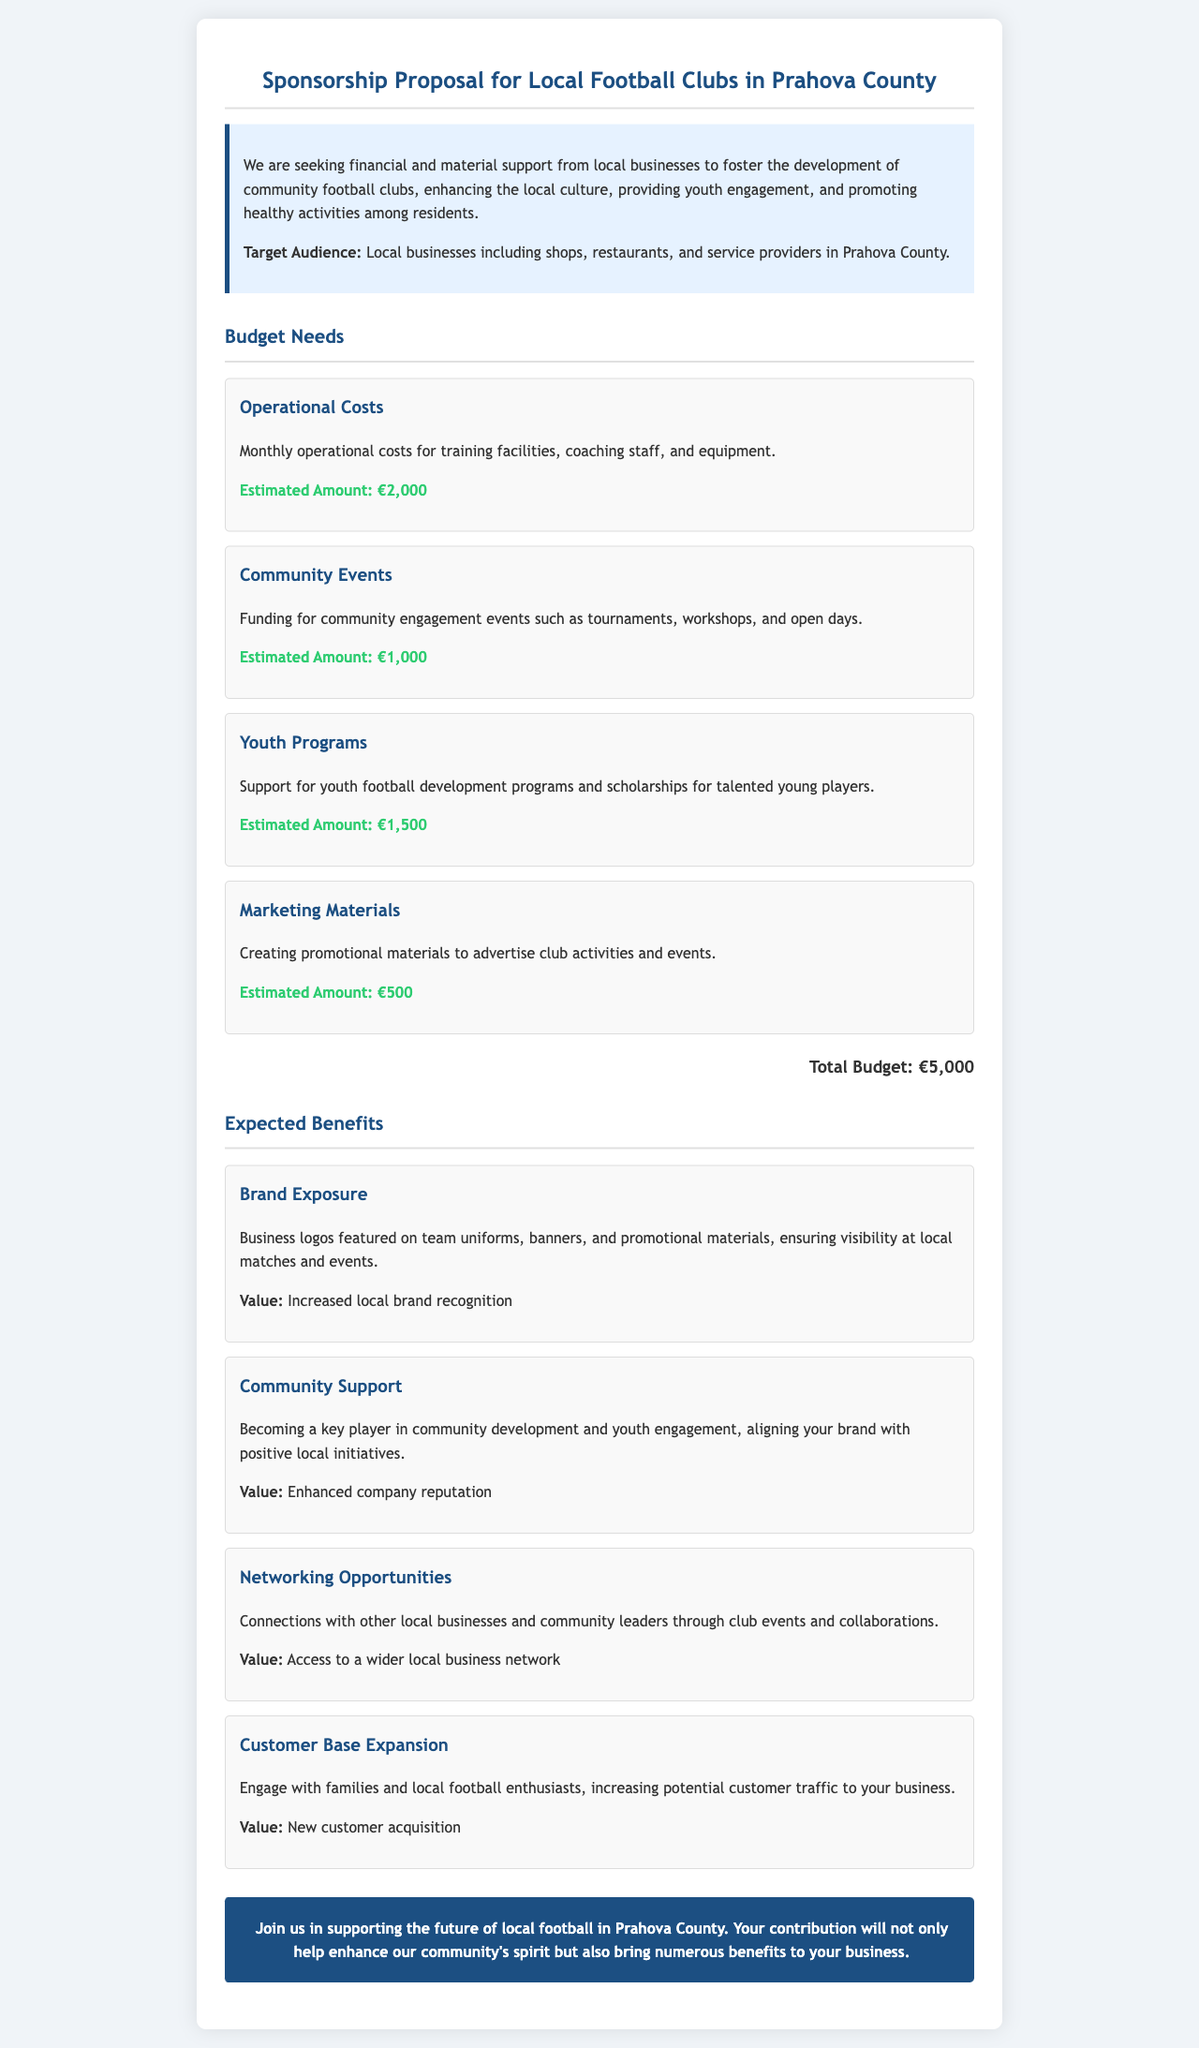What is the total estimated budget? The total estimated budget is listed at the end of the budget section in the document.
Answer: €5,000 How much is estimated for operational costs? The operational costs item specifies the estimated amount required for that category.
Answer: €2,000 What type of events does the budget cover? The document mentions community engagement events as a category in the budget needs section.
Answer: Tournaments What benefit involves business logos? The benefit of brand exposure discusses the feature of business logos being displayed in various contexts.
Answer: Brand Exposure What is one expected benefit related to community development? The document highlights that businesses will become key players in community development as an expected benefit.
Answer: Community Support What is the estimated amount for marketing materials? This information can be found in the budget needs section of the document specifically for marketing materials.
Answer: €500 How many budget items are listed in the proposal? By counting the sections in the budget needs heading, we can determine the total number of distinct budget items.
Answer: 4 Which target audience is specified for sponsorship? The target audience is mentioned in the introductory paragraph of the document.
Answer: Local businesses What kind of opportunities are linked to networking? The document describes the expected benefit of networking opportunities, which involves connections made through events.
Answer: Networking Opportunities 